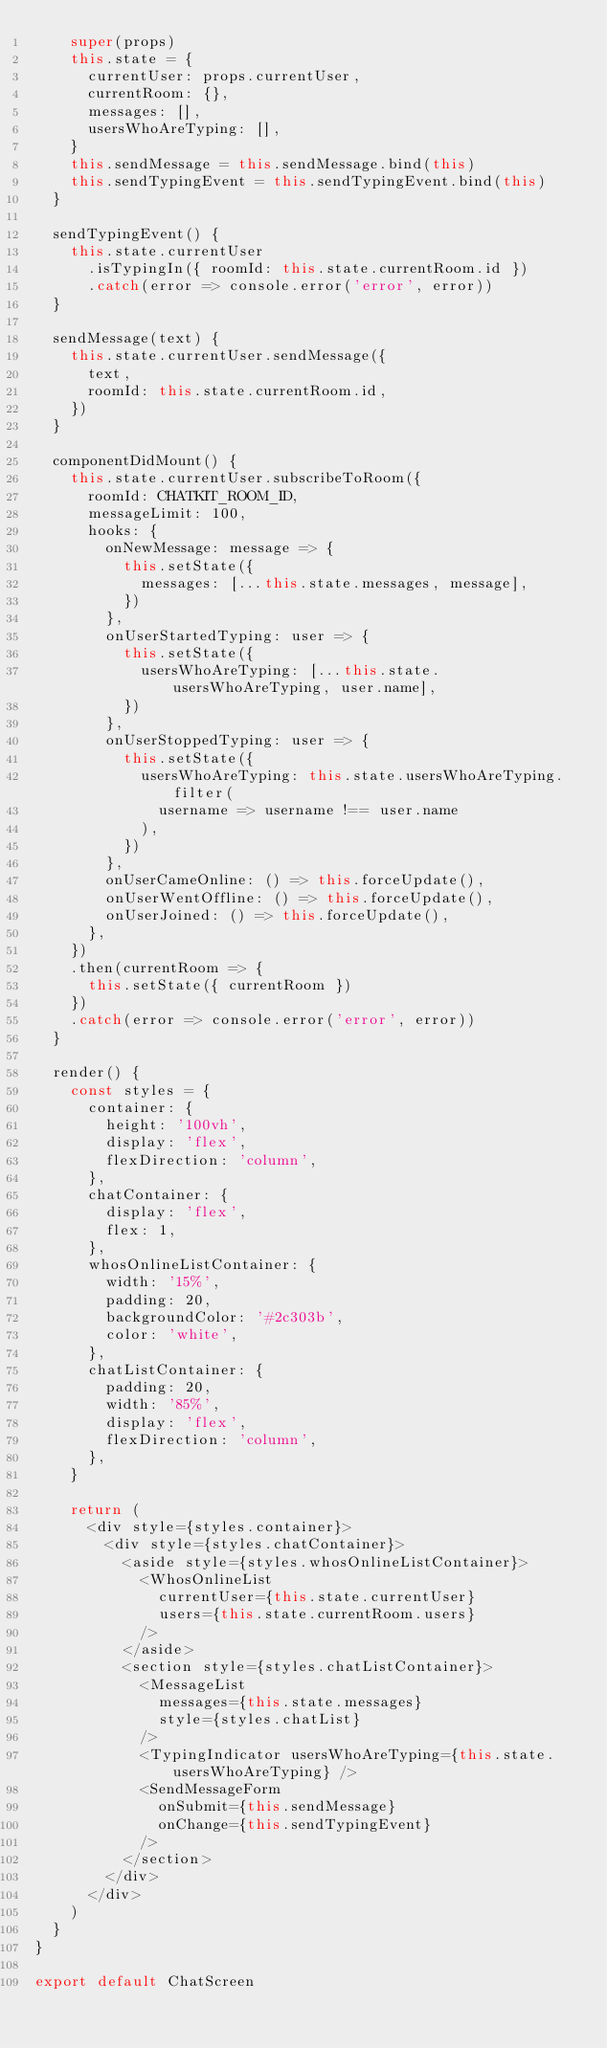<code> <loc_0><loc_0><loc_500><loc_500><_JavaScript_>    super(props)
    this.state = {
      currentUser: props.currentUser,
      currentRoom: {},
      messages: [],
      usersWhoAreTyping: [],
    }
    this.sendMessage = this.sendMessage.bind(this)
    this.sendTypingEvent = this.sendTypingEvent.bind(this)
  }

  sendTypingEvent() {
    this.state.currentUser
      .isTypingIn({ roomId: this.state.currentRoom.id })
      .catch(error => console.error('error', error))
  }

  sendMessage(text) {
    this.state.currentUser.sendMessage({
      text,
      roomId: this.state.currentRoom.id,
    })
  }

  componentDidMount() {
    this.state.currentUser.subscribeToRoom({
      roomId: CHATKIT_ROOM_ID,
      messageLimit: 100,
      hooks: {
        onNewMessage: message => {
          this.setState({
            messages: [...this.state.messages, message],
          })
        },
        onUserStartedTyping: user => {
          this.setState({
            usersWhoAreTyping: [...this.state.usersWhoAreTyping, user.name],
          })
        },
        onUserStoppedTyping: user => {
          this.setState({
            usersWhoAreTyping: this.state.usersWhoAreTyping.filter(
              username => username !== user.name
            ),
          })
        },
        onUserCameOnline: () => this.forceUpdate(),
        onUserWentOffline: () => this.forceUpdate(),
        onUserJoined: () => this.forceUpdate(),
      },
    })
    .then(currentRoom => {
      this.setState({ currentRoom })
    })
    .catch(error => console.error('error', error))
  }

  render() {
    const styles = {
      container: {
        height: '100vh',
        display: 'flex',
        flexDirection: 'column',
      },
      chatContainer: {
        display: 'flex',
        flex: 1,
      },
      whosOnlineListContainer: {
        width: '15%',
        padding: 20,
        backgroundColor: '#2c303b',
        color: 'white',
      },
      chatListContainer: {
        padding: 20,
        width: '85%',
        display: 'flex',
        flexDirection: 'column',
      },
    }

    return (
      <div style={styles.container}>
        <div style={styles.chatContainer}>
          <aside style={styles.whosOnlineListContainer}>
            <WhosOnlineList
              currentUser={this.state.currentUser}
              users={this.state.currentRoom.users}
            />
          </aside>
          <section style={styles.chatListContainer}>
            <MessageList
              messages={this.state.messages}
              style={styles.chatList}
            />
            <TypingIndicator usersWhoAreTyping={this.state.usersWhoAreTyping} />
            <SendMessageForm
              onSubmit={this.sendMessage}
              onChange={this.sendTypingEvent}
            />
          </section>
        </div>
      </div>
    )
  }
}

export default ChatScreen
</code> 